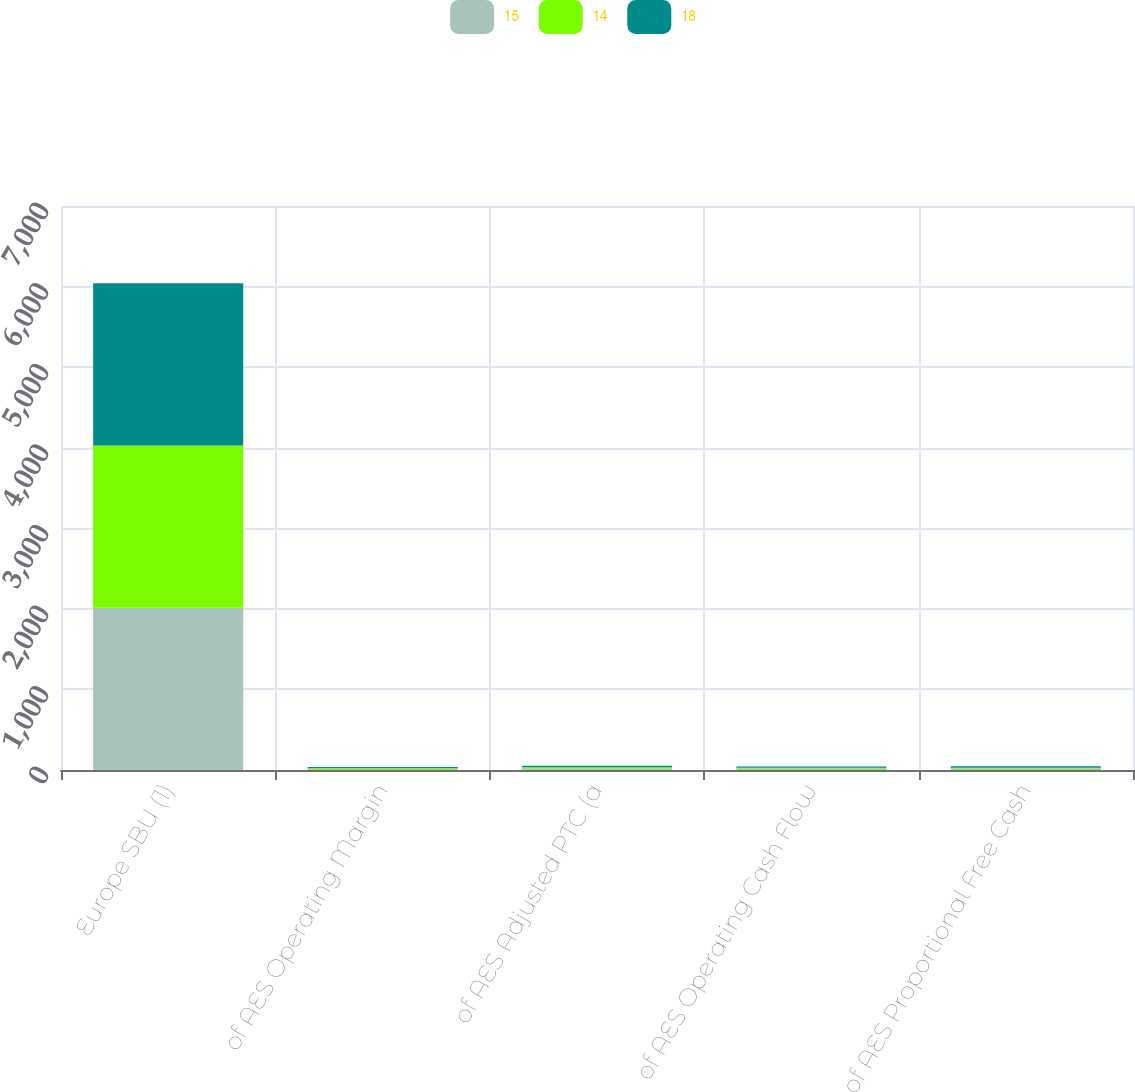<chart> <loc_0><loc_0><loc_500><loc_500><stacked_bar_chart><ecel><fcel>Europe SBU (1)<fcel>of AES Operating Margin<fcel>of AES Adjusted PTC (a<fcel>of AES Operating Cash Flow<fcel>of AES Proportional Free Cash<nl><fcel>15<fcel>2015<fcel>11<fcel>15<fcel>14<fcel>15<nl><fcel>14<fcel>2014<fcel>13<fcel>19<fcel>13<fcel>14<nl><fcel>18<fcel>2013<fcel>13<fcel>19<fcel>15<fcel>18<nl></chart> 